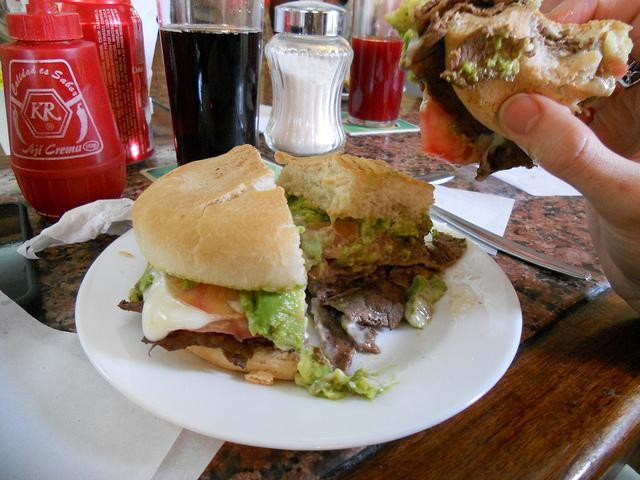What is she doing with the sandwich?

Choices:
A) stealing it
B) cleaning it
C) sharing it
D) eating it eating it 